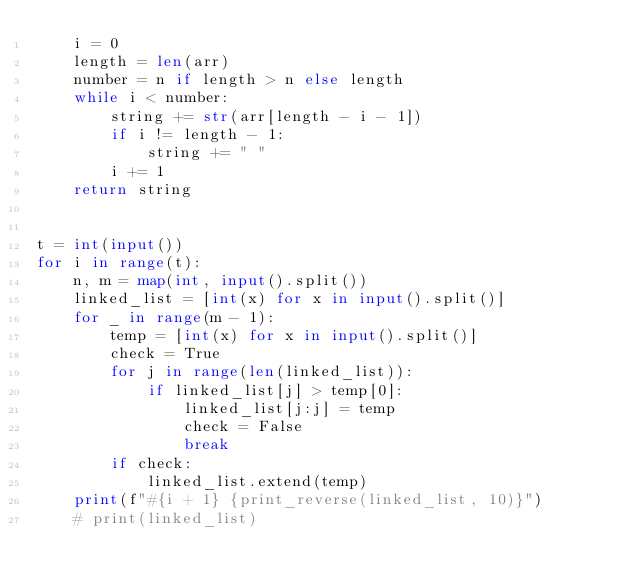Convert code to text. <code><loc_0><loc_0><loc_500><loc_500><_Python_>    i = 0
    length = len(arr)
    number = n if length > n else length
    while i < number:
        string += str(arr[length - i - 1])
        if i != length - 1:
            string += " "
        i += 1
    return string


t = int(input())
for i in range(t):
    n, m = map(int, input().split())
    linked_list = [int(x) for x in input().split()]
    for _ in range(m - 1):
        temp = [int(x) for x in input().split()]
        check = True
        for j in range(len(linked_list)):
            if linked_list[j] > temp[0]:
                linked_list[j:j] = temp
                check = False
                break
        if check:
            linked_list.extend(temp)
    print(f"#{i + 1} {print_reverse(linked_list, 10)}")
    # print(linked_list)
</code> 